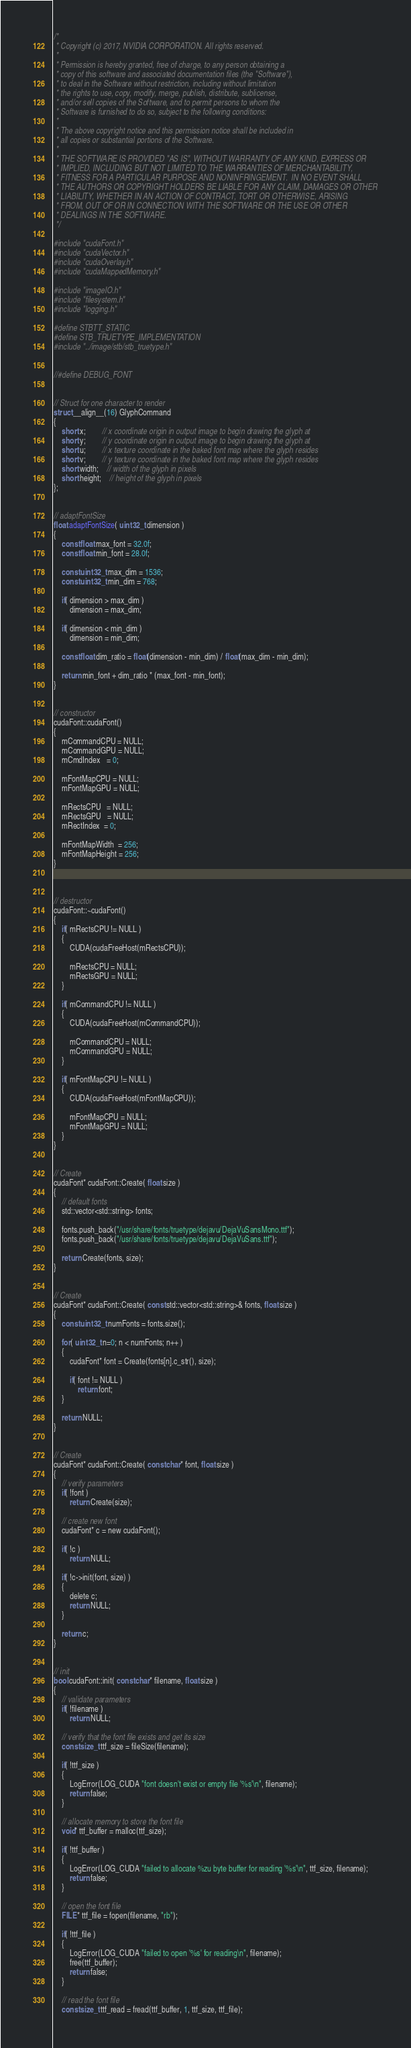<code> <loc_0><loc_0><loc_500><loc_500><_Cuda_>/*
 * Copyright (c) 2017, NVIDIA CORPORATION. All rights reserved.
 *
 * Permission is hereby granted, free of charge, to any person obtaining a
 * copy of this software and associated documentation files (the "Software"),
 * to deal in the Software without restriction, including without limitation
 * the rights to use, copy, modify, merge, publish, distribute, sublicense,
 * and/or sell copies of the Software, and to permit persons to whom the
 * Software is furnished to do so, subject to the following conditions:
 *
 * The above copyright notice and this permission notice shall be included in
 * all copies or substantial portions of the Software.
 *
 * THE SOFTWARE IS PROVIDED "AS IS", WITHOUT WARRANTY OF ANY KIND, EXPRESS OR
 * IMPLIED, INCLUDING BUT NOT LIMITED TO THE WARRANTIES OF MERCHANTABILITY,
 * FITNESS FOR A PARTICULAR PURPOSE AND NONINFRINGEMENT.  IN NO EVENT SHALL
 * THE AUTHORS OR COPYRIGHT HOLDERS BE LIABLE FOR ANY CLAIM, DAMAGES OR OTHER
 * LIABILITY, WHETHER IN AN ACTION OF CONTRACT, TORT OR OTHERWISE, ARISING
 * FROM, OUT OF OR IN CONNECTION WITH THE SOFTWARE OR THE USE OR OTHER
 * DEALINGS IN THE SOFTWARE.
 */

#include "cudaFont.h"
#include "cudaVector.h"
#include "cudaOverlay.h"
#include "cudaMappedMemory.h"

#include "imageIO.h"
#include "filesystem.h"
#include "logging.h"

#define STBTT_STATIC
#define STB_TRUETYPE_IMPLEMENTATION
#include "../image/stb/stb_truetype.h"


//#define DEBUG_FONT


// Struct for one character to render
struct __align__(16) GlyphCommand
{
	short x;		// x coordinate origin in output image to begin drawing the glyph at
	short y;		// y coordinate origin in output image to begin drawing the glyph at
	short u;		// x texture coordinate in the baked font map where the glyph resides
	short v;		// y texture coordinate in the baked font map where the glyph resides
	short width;	// width of the glyph in pixels
	short height;	// height of the glyph in pixels
};


// adaptFontSize
float adaptFontSize( uint32_t dimension )
{
	const float max_font = 32.0f;
	const float min_font = 28.0f;

	const uint32_t max_dim = 1536;
	const uint32_t min_dim = 768;

	if( dimension > max_dim )
		dimension = max_dim;

	if( dimension < min_dim )
		dimension = min_dim;

	const float dim_ratio = float(dimension - min_dim) / float(max_dim - min_dim);

	return min_font + dim_ratio * (max_font - min_font);
}


// constructor
cudaFont::cudaFont()
{
	mCommandCPU = NULL;
	mCommandGPU = NULL;
	mCmdIndex   = 0;

	mFontMapCPU = NULL;
	mFontMapGPU = NULL;

	mRectsCPU   = NULL;
	mRectsGPU   = NULL;
	mRectIndex  = 0;

	mFontMapWidth  = 256;
	mFontMapHeight = 256;
}



// destructor
cudaFont::~cudaFont()
{
	if( mRectsCPU != NULL )
	{
		CUDA(cudaFreeHost(mRectsCPU));

		mRectsCPU = NULL;
		mRectsGPU = NULL;
	}

	if( mCommandCPU != NULL )
	{
		CUDA(cudaFreeHost(mCommandCPU));

		mCommandCPU = NULL;
		mCommandGPU = NULL;
	}

	if( mFontMapCPU != NULL )
	{
		CUDA(cudaFreeHost(mFontMapCPU));

		mFontMapCPU = NULL;
		mFontMapGPU = NULL;
	}
}


// Create
cudaFont* cudaFont::Create( float size )
{
	// default fonts
	std::vector<std::string> fonts;

	fonts.push_back("/usr/share/fonts/truetype/dejavu/DejaVuSansMono.ttf");
	fonts.push_back("/usr/share/fonts/truetype/dejavu/DejaVuSans.ttf");

	return Create(fonts, size);
}


// Create
cudaFont* cudaFont::Create( const std::vector<std::string>& fonts, float size )
{
	const uint32_t numFonts = fonts.size();

	for( uint32_t n=0; n < numFonts; n++ )
	{
		cudaFont* font = Create(fonts[n].c_str(), size);

		if( font != NULL )
			return font;
	}

	return NULL;
}


// Create
cudaFont* cudaFont::Create( const char* font, float size )
{
	// verify parameters
	if( !font )
		return Create(size);

	// create new font
	cudaFont* c = new cudaFont();

	if( !c )
		return NULL;

	if( !c->init(font, size) )
	{
		delete c;
		return NULL;
	}

	return c;
}


// init
bool cudaFont::init( const char* filename, float size )
{
	// validate parameters
	if( !filename )
		return NULL;

	// verify that the font file exists and get its size
	const size_t ttf_size = fileSize(filename);

	if( !ttf_size )
	{
		LogError(LOG_CUDA "font doesn't exist or empty file '%s'\n", filename);
 		return false;
	}

	// allocate memory to store the font file
	void* ttf_buffer = malloc(ttf_size);

	if( !ttf_buffer )
	{
		LogError(LOG_CUDA "failed to allocate %zu byte buffer for reading '%s'\n", ttf_size, filename);
		return false;
	}

	// open the font file
	FILE* ttf_file = fopen(filename, "rb");

	if( !ttf_file )
	{
		LogError(LOG_CUDA "failed to open '%s' for reading\n", filename);
		free(ttf_buffer);
		return false;
	}

	// read the font file
	const size_t ttf_read = fread(ttf_buffer, 1, ttf_size, ttf_file);</code> 